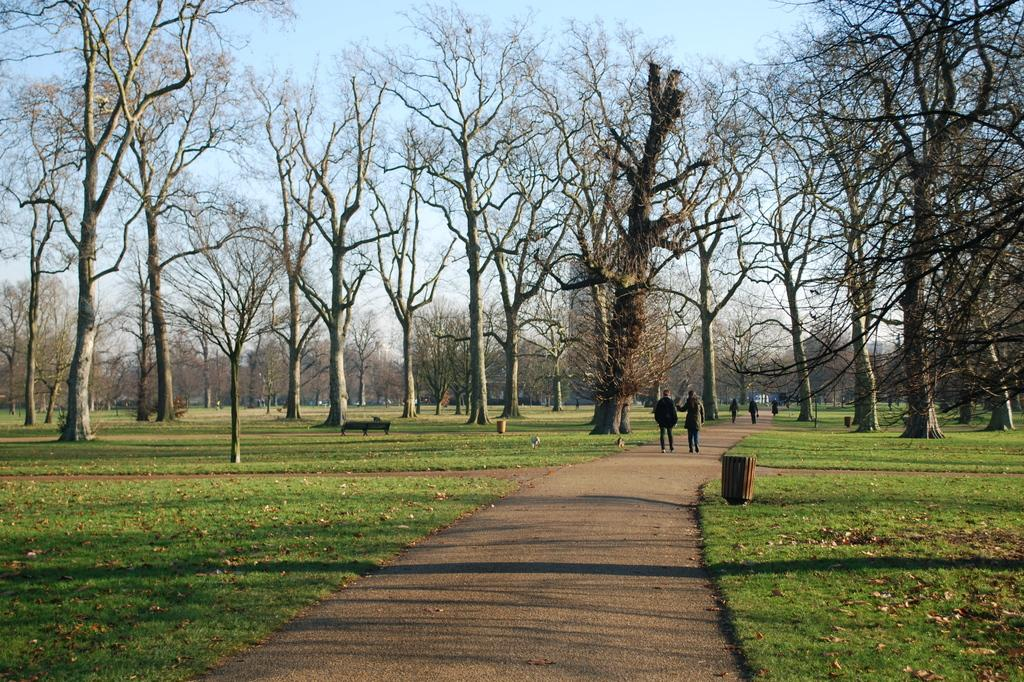What are the people in the image doing? The people in the image are walking on the road. What type of vegetation can be seen on either side of the road? There is grass and trees on either side of the road. What type of seating is available on either side of the road? There are benches on either side of the road. What type of receptacle is available on either side of the road? There are trash cans on either side of the road. What is visible in the background of the image? The sky is visible in the background of the image. Can you see any goldfish swimming in the image? There are no goldfish present in the image. What type of amusement park can be seen in the background of the image? There is no amusement park visible in the image; it features a road with people walking, grass, trees, benches, trash cans, and a sky background. 